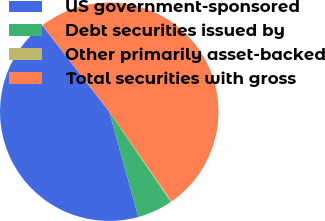<chart> <loc_0><loc_0><loc_500><loc_500><pie_chart><fcel>US government-sponsored<fcel>Debt securities issued by<fcel>Other primarily asset-backed<fcel>Total securities with gross<nl><fcel>43.79%<fcel>5.23%<fcel>0.17%<fcel>50.81%<nl></chart> 